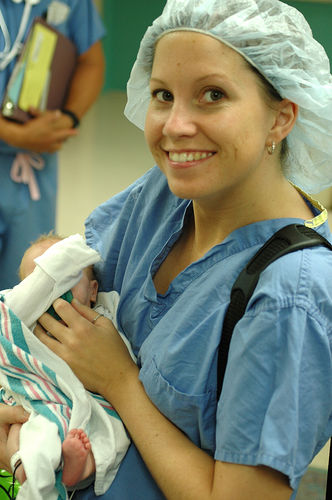What can be inferred about the woman's profession or role from her attire? The woman's attire, which includes a surgical cap and scrubs, suggests that she is a medical professional, likely a nurse or a doctor. Her presence in what appears to be a clinical setting, holding a newborn, further implies that she might be part of a team that delivers babies or takes care of them immediately postpartum. What significance does her attire have in a hospital setting? In a hospital setting, the attire worn by the woman is significant for maintaining hygiene and minimizing the risk of infection. The scrubs are designed to be simple, easy to clean, and replaceable, while the surgical cap helps contain hair, preventing contamination. This attire is part of standard precautions in environments where cleanliness is paramount, such as in delivery rooms or operating theaters. 